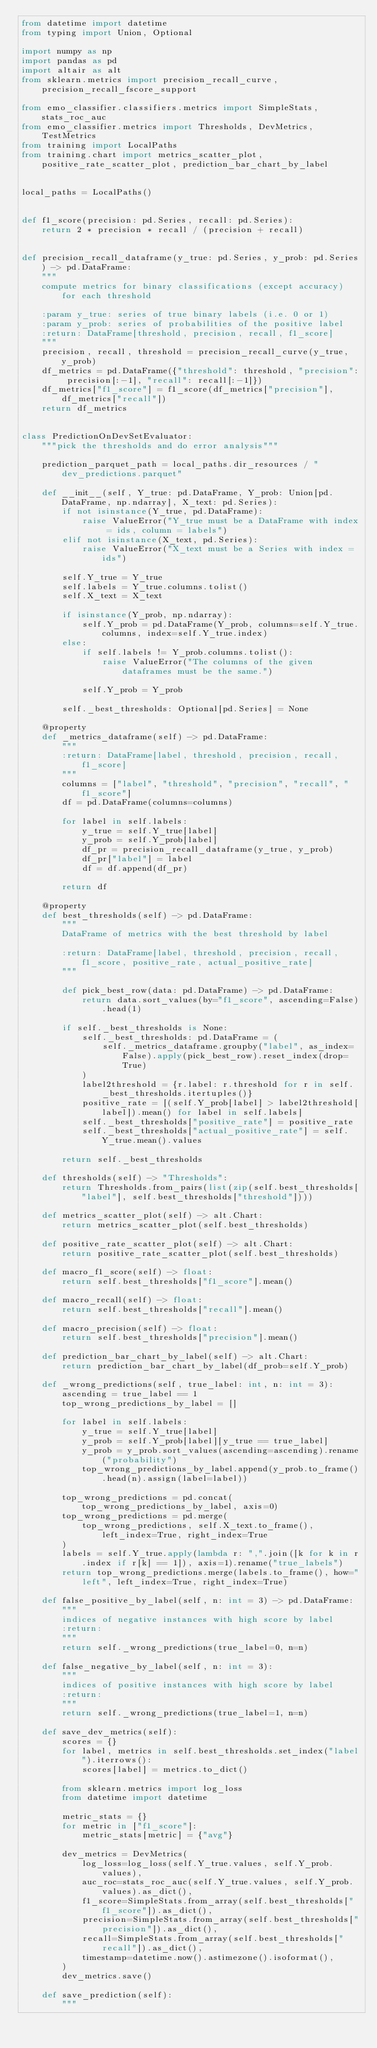<code> <loc_0><loc_0><loc_500><loc_500><_Python_>from datetime import datetime
from typing import Union, Optional

import numpy as np
import pandas as pd
import altair as alt
from sklearn.metrics import precision_recall_curve, precision_recall_fscore_support

from emo_classifier.classifiers.metrics import SimpleStats, stats_roc_auc
from emo_classifier.metrics import Thresholds, DevMetrics, TestMetrics
from training import LocalPaths
from training.chart import metrics_scatter_plot, positive_rate_scatter_plot, prediction_bar_chart_by_label


local_paths = LocalPaths()


def f1_score(precision: pd.Series, recall: pd.Series):
    return 2 * precision * recall / (precision + recall)


def precision_recall_dataframe(y_true: pd.Series, y_prob: pd.Series) -> pd.DataFrame:
    """
    compute metrics for binary classifications (except accuracy) for each threshold

    :param y_true: series of true binary labels (i.e. 0 or 1)
    :param y_prob: series of probabilities of the positive label
    :return: DataFrame[threshold, precision, recall, f1_score]
    """
    precision, recall, threshold = precision_recall_curve(y_true, y_prob)
    df_metrics = pd.DataFrame({"threshold": threshold, "precision": precision[:-1], "recall": recall[:-1]})
    df_metrics["f1_score"] = f1_score(df_metrics["precision"], df_metrics["recall"])
    return df_metrics


class PredictionOnDevSetEvaluator:
    """pick the thresholds and do error analysis"""

    prediction_parquet_path = local_paths.dir_resources / "dev_predictions.parquet"

    def __init__(self, Y_true: pd.DataFrame, Y_prob: Union[pd.DataFrame, np.ndarray], X_text: pd.Series):
        if not isinstance(Y_true, pd.DataFrame):
            raise ValueError("Y_true must be a DataFrame with index = ids, column = labels")
        elif not isinstance(X_text, pd.Series):
            raise ValueError("X_text must be a Series with index = ids")

        self.Y_true = Y_true
        self.labels = Y_true.columns.tolist()
        self.X_text = X_text

        if isinstance(Y_prob, np.ndarray):
            self.Y_prob = pd.DataFrame(Y_prob, columns=self.Y_true.columns, index=self.Y_true.index)
        else:
            if self.labels != Y_prob.columns.tolist():
                raise ValueError("The columns of the given dataframes must be the same.")

            self.Y_prob = Y_prob

        self._best_thresholds: Optional[pd.Series] = None

    @property
    def _metrics_dataframe(self) -> pd.DataFrame:
        """
        :return: DataFrame[label, threshold, precision, recall, f1_score]
        """
        columns = ["label", "threshold", "precision", "recall", "f1_score"]
        df = pd.DataFrame(columns=columns)

        for label in self.labels:
            y_true = self.Y_true[label]
            y_prob = self.Y_prob[label]
            df_pr = precision_recall_dataframe(y_true, y_prob)
            df_pr["label"] = label
            df = df.append(df_pr)

        return df

    @property
    def best_thresholds(self) -> pd.DataFrame:
        """
        DataFrame of metrics with the best threshold by label

        :return: DataFrame[label, threshold, precision, recall, f1_score, positive_rate, actual_positive_rate]
        """

        def pick_best_row(data: pd.DataFrame) -> pd.DataFrame:
            return data.sort_values(by="f1_score", ascending=False).head(1)

        if self._best_thresholds is None:
            self._best_thresholds: pd.DataFrame = (
                self._metrics_dataframe.groupby("label", as_index=False).apply(pick_best_row).reset_index(drop=True)
            )
            label2threshold = {r.label: r.threshold for r in self._best_thresholds.itertuples()}
            positive_rate = [(self.Y_prob[label] > label2threshold[label]).mean() for label in self.labels]
            self._best_thresholds["positive_rate"] = positive_rate
            self._best_thresholds["actual_positive_rate"] = self.Y_true.mean().values

        return self._best_thresholds

    def thresholds(self) -> "Thresholds":
        return Thresholds.from_pairs(list(zip(self.best_thresholds["label"], self.best_thresholds["threshold"])))

    def metrics_scatter_plot(self) -> alt.Chart:
        return metrics_scatter_plot(self.best_thresholds)

    def positive_rate_scatter_plot(self) -> alt.Chart:
        return positive_rate_scatter_plot(self.best_thresholds)

    def macro_f1_score(self) -> float:
        return self.best_thresholds["f1_score"].mean()

    def macro_recall(self) -> float:
        return self.best_thresholds["recall"].mean()

    def macro_precision(self) -> float:
        return self.best_thresholds["precision"].mean()

    def prediction_bar_chart_by_label(self) -> alt.Chart:
        return prediction_bar_chart_by_label(df_prob=self.Y_prob)

    def _wrong_predictions(self, true_label: int, n: int = 3):
        ascending = true_label == 1
        top_wrong_predictions_by_label = []

        for label in self.labels:
            y_true = self.Y_true[label]
            y_prob = self.Y_prob[label][y_true == true_label]
            y_prob = y_prob.sort_values(ascending=ascending).rename("probability")
            top_wrong_predictions_by_label.append(y_prob.to_frame().head(n).assign(label=label))

        top_wrong_predictions = pd.concat(top_wrong_predictions_by_label, axis=0)
        top_wrong_predictions = pd.merge(
            top_wrong_predictions, self.X_text.to_frame(), left_index=True, right_index=True
        )
        labels = self.Y_true.apply(lambda r: ",".join([k for k in r.index if r[k] == 1]), axis=1).rename("true_labels")
        return top_wrong_predictions.merge(labels.to_frame(), how="left", left_index=True, right_index=True)

    def false_positive_by_label(self, n: int = 3) -> pd.DataFrame:
        """
        indices of negative instances with high score by label
        :return:
        """
        return self._wrong_predictions(true_label=0, n=n)

    def false_negative_by_label(self, n: int = 3):
        """
        indices of positive instances with high score by label
        :return:
        """
        return self._wrong_predictions(true_label=1, n=n)

    def save_dev_metrics(self):
        scores = {}
        for label, metrics in self.best_thresholds.set_index("label").iterrows():
            scores[label] = metrics.to_dict()

        from sklearn.metrics import log_loss
        from datetime import datetime

        metric_stats = {}
        for metric in ["f1_score"]:
            metric_stats[metric] = {"avg"}

        dev_metrics = DevMetrics(
            log_loss=log_loss(self.Y_true.values, self.Y_prob.values),
            auc_roc=stats_roc_auc(self.Y_true.values, self.Y_prob.values).as_dict(),
            f1_score=SimpleStats.from_array(self.best_thresholds["f1_score"]).as_dict(),
            precision=SimpleStats.from_array(self.best_thresholds["precision"]).as_dict(),
            recall=SimpleStats.from_array(self.best_thresholds["recall"]).as_dict(),
            timestamp=datetime.now().astimezone().isoformat(),
        )
        dev_metrics.save()

    def save_prediction(self):
        """</code> 